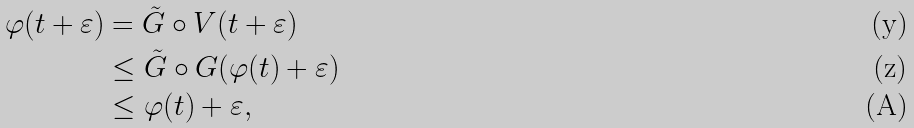Convert formula to latex. <formula><loc_0><loc_0><loc_500><loc_500>\varphi ( t + \varepsilon ) & = \tilde { G } \circ V ( t + \varepsilon ) \\ & \leq \tilde { G } \circ G ( \varphi ( t ) + \varepsilon ) \\ & \leq \varphi ( t ) + \varepsilon ,</formula> 